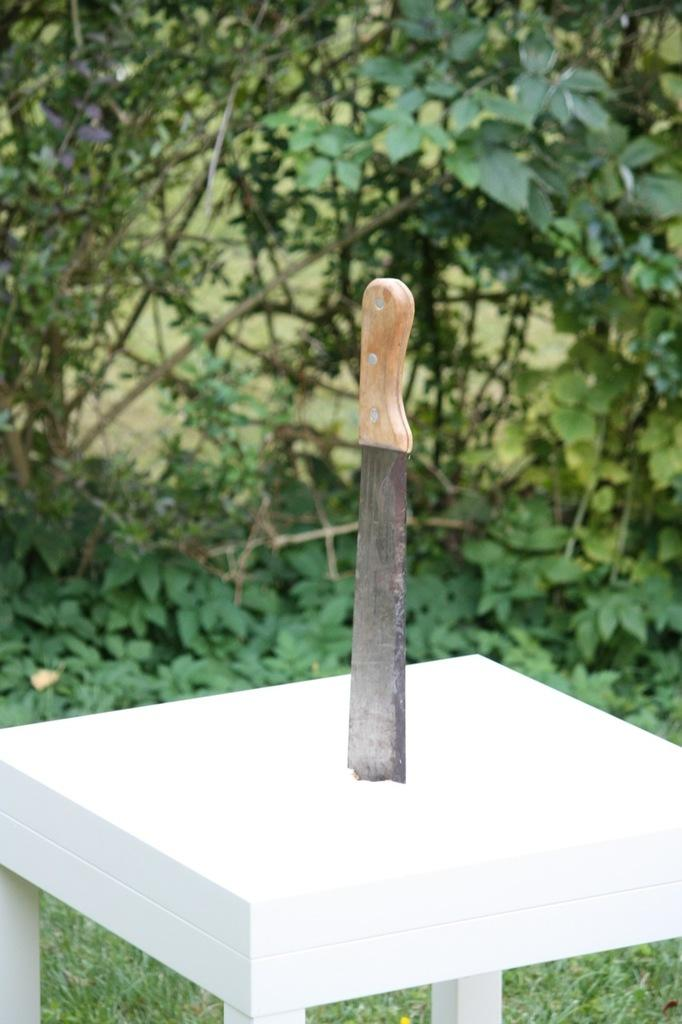What object is placed on the table in the image? There is a knife on a table in the image. What color is the table? The table is white. What can be seen in the background of the image? There are plants in the background of the image. How is the background of the image depicted? The background of the image is blurred. What song is being sung by the person in the image? There is no person present in the image, and therefore no song being sung. Can you tell me how the person in the image is expressing anger? There is no person present in the image, and therefore no expression of anger can be observed. 